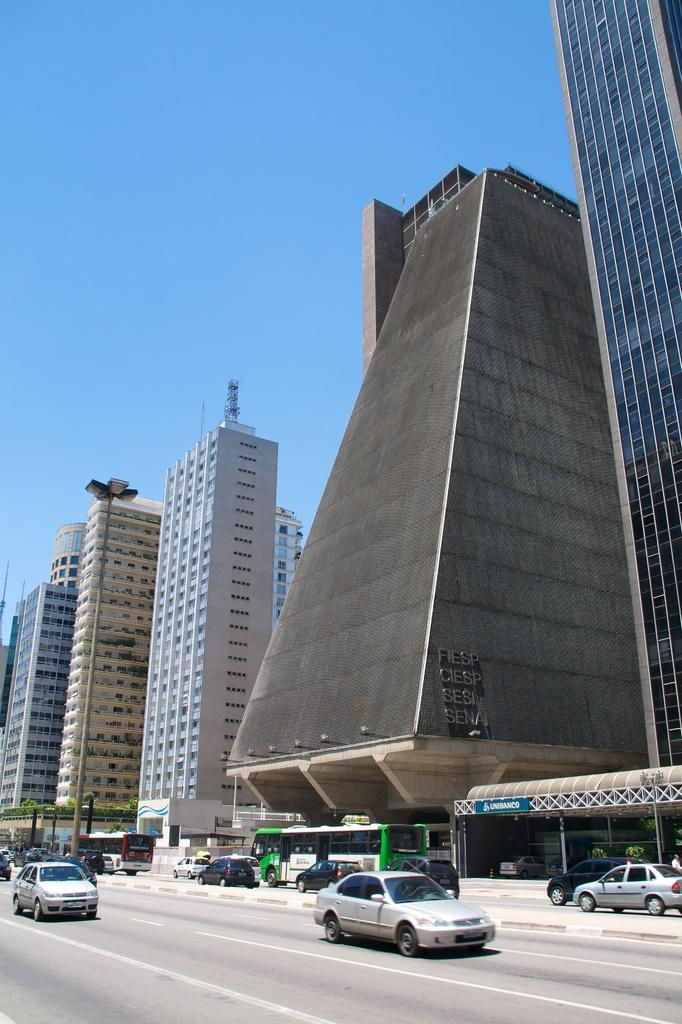What can be seen on the road in the image? There are many vehicles on the road in the image. What type of vegetation is visible in the background of the image? There are plants visible in the background of the image. What structures can be seen in the background of the image? There are buildings in the background of the image. What part of the natural environment is visible in the image? The sky is visible in the background of the image. Where is the hat located in the image? There is no hat present in the image. What type of crib can be seen in the image? There is no crib present in the image. 